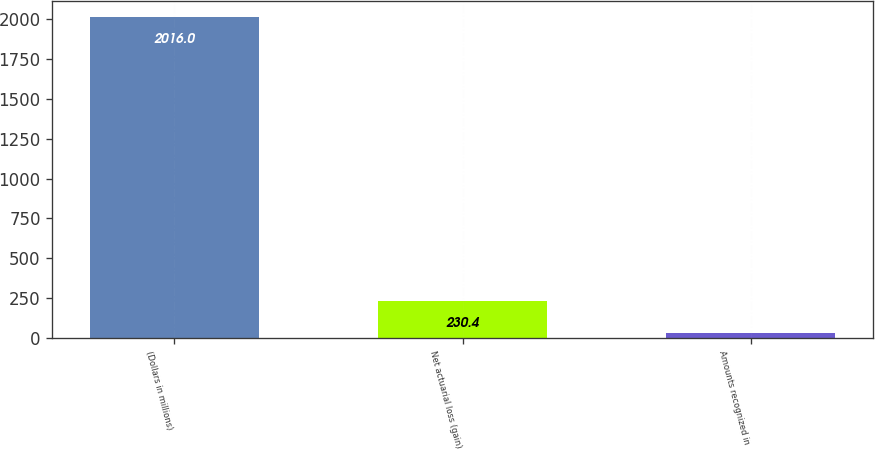Convert chart to OTSL. <chart><loc_0><loc_0><loc_500><loc_500><bar_chart><fcel>(Dollars in millions)<fcel>Net actuarial loss (gain)<fcel>Amounts recognized in<nl><fcel>2016<fcel>230.4<fcel>32<nl></chart> 